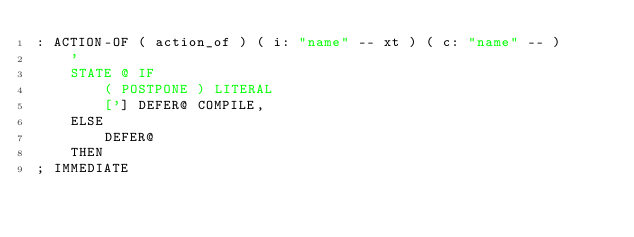Convert code to text. <code><loc_0><loc_0><loc_500><loc_500><_Forth_>: ACTION-OF ( action_of ) ( i: "name" -- xt ) ( c: "name" -- )
	'
	STATE @ IF
		( POSTPONE ) LITERAL
		['] DEFER@ COMPILE,
	ELSE
		DEFER@
	THEN
; IMMEDIATE
</code> 